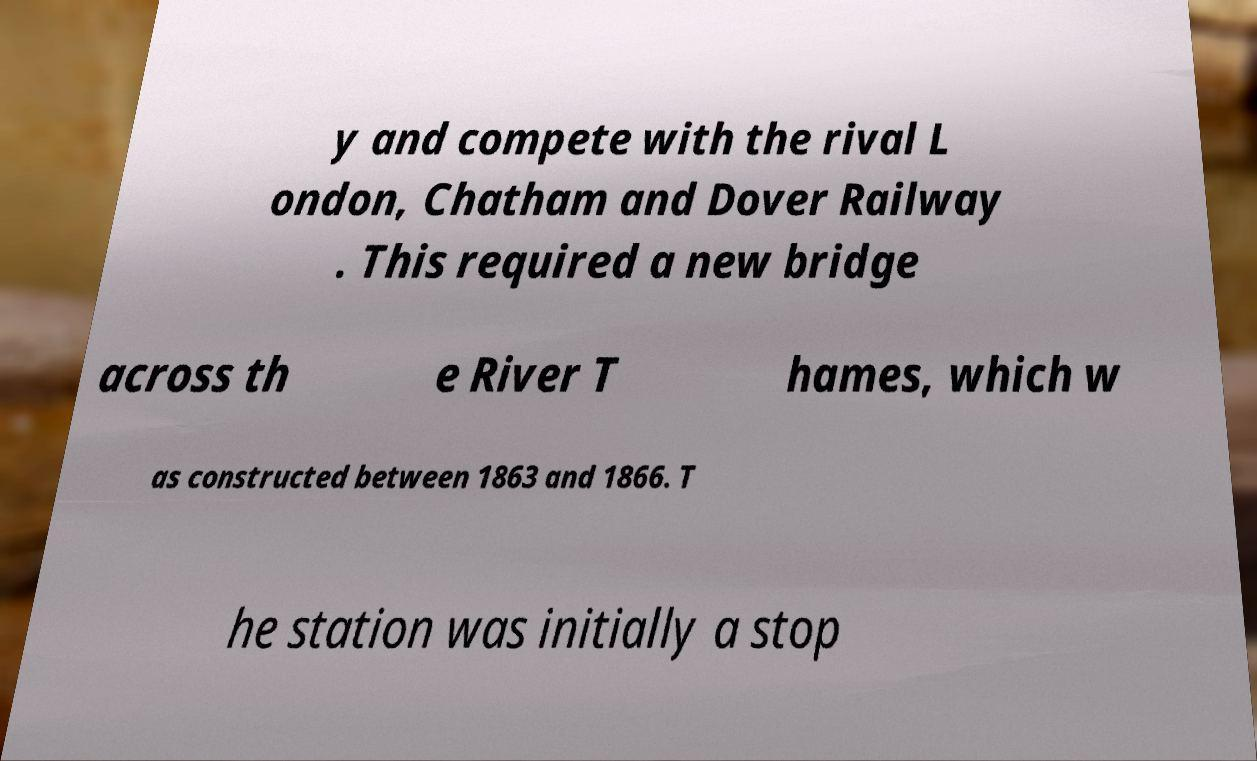Could you extract and type out the text from this image? y and compete with the rival L ondon, Chatham and Dover Railway . This required a new bridge across th e River T hames, which w as constructed between 1863 and 1866. T he station was initially a stop 